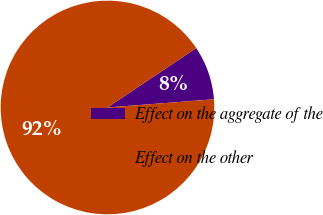Convert chart to OTSL. <chart><loc_0><loc_0><loc_500><loc_500><pie_chart><fcel>Effect on the aggregate of the<fcel>Effect on the other<nl><fcel>8.16%<fcel>91.84%<nl></chart> 